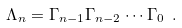Convert formula to latex. <formula><loc_0><loc_0><loc_500><loc_500>\Lambda _ { n } = \Gamma _ { n - 1 } \Gamma _ { n - 2 } \cdots \Gamma _ { 0 } \ .</formula> 